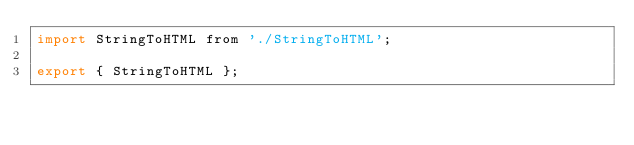<code> <loc_0><loc_0><loc_500><loc_500><_JavaScript_>import StringToHTML from './StringToHTML';

export { StringToHTML };
</code> 